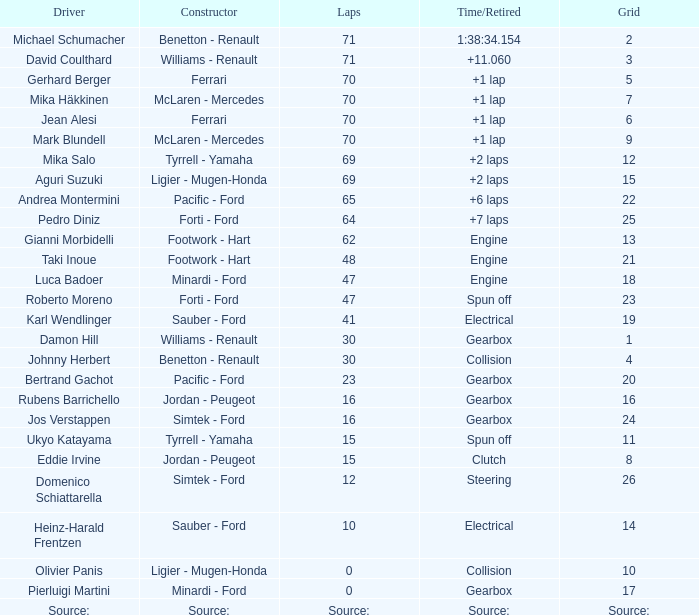David Coulthard was the driver in which grid? 3.0. 